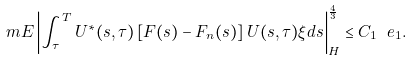Convert formula to latex. <formula><loc_0><loc_0><loc_500><loc_500>\ m E \left | \int _ { \tau } ^ { T } U ^ { * } ( s , \tau ) \left [ F ( s ) - F _ { n } ( s ) \right ] U ( s , \tau ) \xi d s \right | _ { H } ^ { \frac { 4 } { 3 } } \leq C _ { 1 } \ e _ { 1 } .</formula> 